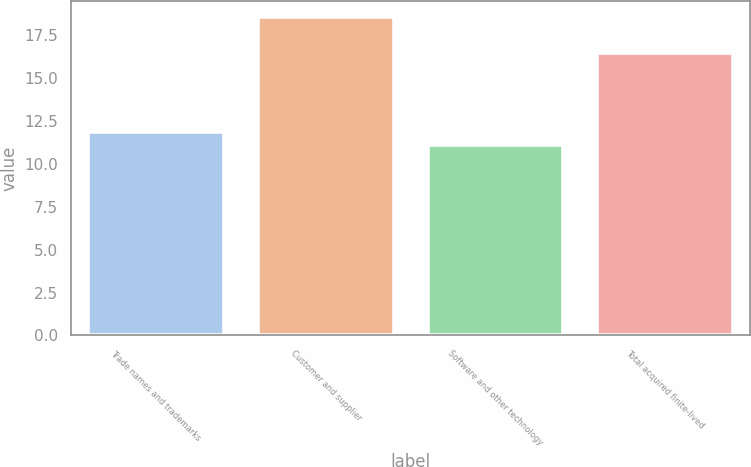Convert chart to OTSL. <chart><loc_0><loc_0><loc_500><loc_500><bar_chart><fcel>Trade names and trademarks<fcel>Customer and supplier<fcel>Software and other technology<fcel>Total acquired finite-lived<nl><fcel>11.85<fcel>18.6<fcel>11.1<fcel>16.5<nl></chart> 